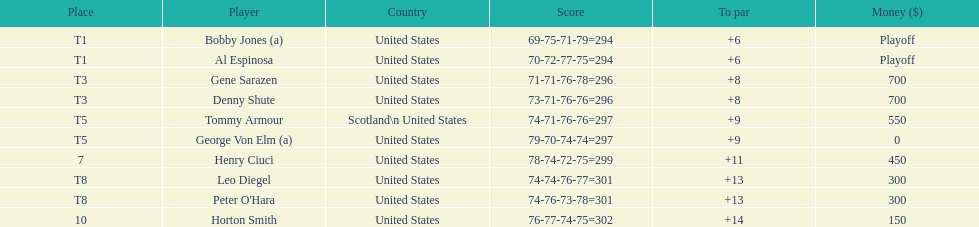In the 1929 us open final, what was al espinosa's overall stroke count? 294. 